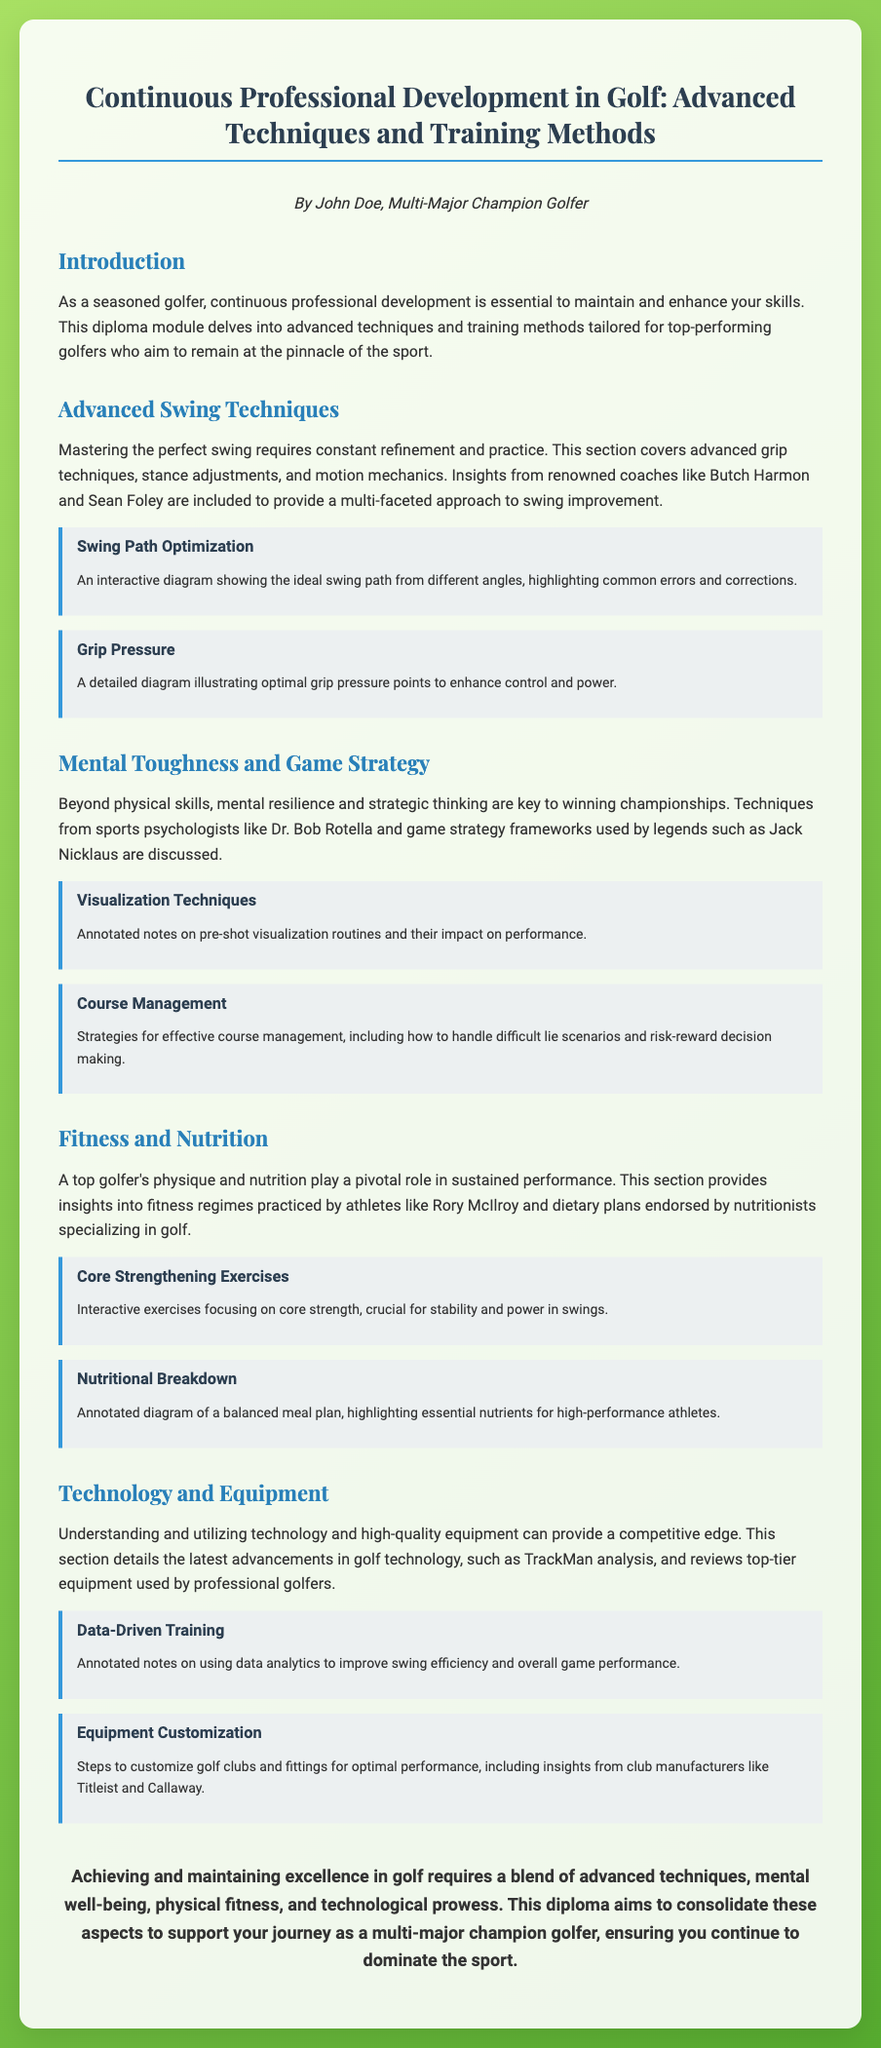What is the title of the diploma? The title of the diploma is presented prominently at the top of the document.
Answer: Continuous Professional Development in Golf: Advanced Techniques and Training Methods Who authored the diploma? The author information is provided in the introductory section of the document.
Answer: John Doe What is one advanced swing technique discussed? The document specifies various techniques under swing improvement.
Answer: Grip techniques Who are two renowned coaches mentioned for swing techniques? The document lists McIlroy and Nicklaus when discussing swing improvement methodologies.
Answer: Butch Harmon and Sean Foley Which psychologist's techniques are referenced in the mental toughness section? The document cites a specific sports psychologist associated with mental resilience.
Answer: Dr. Bob Rotella What physical aspect is crucial for swing stability according to the fitness section? The diploma highlights a specific area of fitness that supports swing performance.
Answer: Core strength What technology is referenced for data-driven training? The document mentions a specific technology used for swing analysis in its technology section.
Answer: TrackMan Which two companies are mentioned for equipment customization insights? The diploma discusses insights from well-known golf club manufacturers.
Answer: Titleist and Callaway What is emphasized as key to winning championships? The document suggests the importance of mental and strategic elements in achieving success.
Answer: Mental resilience and strategic thinking 